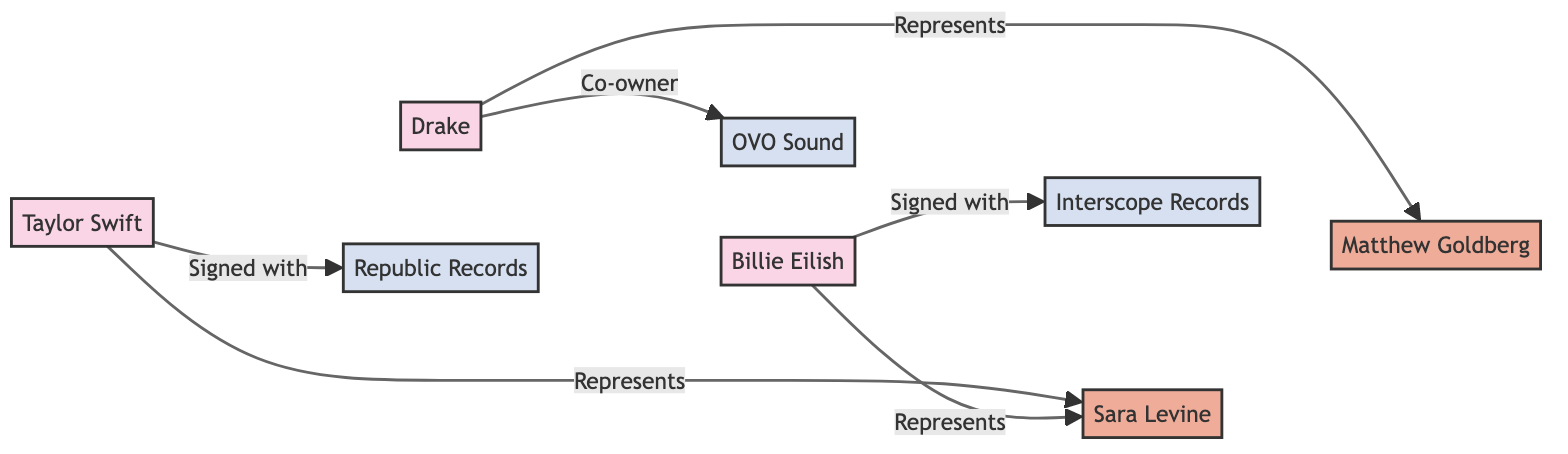What artist is represented by Sara Levine? In the diagram, Sara Levine is connected to both Taylor Swift and Billie Eilish with the label "Represents." This indicates that she represents both artists.
Answer: Taylor Swift, Billie Eilish Which record label is Drake associated with? The edge labeled "Co-owner" connects Drake to OVO Sound, showing his direct association with this record label.
Answer: OVO Sound How many artists are signed with record labels? There are three edges connecting artists to record labels ("Signed with" labels). Taylor Swift is signed with Republic Records, and Billie Eilish is signed with Interscope Records. Therefore, 2 artists are signed.
Answer: 2 Who is the lawyer representing Billie Eilish? The diagram indicates that Billie Eilish is connected to Sara Levine with the label "Represents." Hence, Sara Levine is her lawyer.
Answer: Sara Levine Which artist has a direct connection with Republic Records? The diagram shows an edge labeled "Signed with" from Taylor Swift to Republic Records, indicating that she has a direct connection with this label.
Answer: Taylor Swift What is the total number of nodes in this diagram? By counting all unique entities represented in the diagram, there are 7 nodes: 3 artists, 2 lawyers, and 3 record labels. Therefore, the total is 7.
Answer: 7 How many edges indicate 'Represents' relationships? The diagram contains 3 edges labeled "Represents," one for Taylor Swift to Sara Levine, one for Billie Eilish to Sara Levine, and one for Drake to Matthew Goldberg.
Answer: 3 Which lawyer represents both Taylor Swift and Billie Eilish? The edge labeled "Represents" connects both Taylor Swift and Billie Eilish to Sara Levine, indicating she represents both artists.
Answer: Sara Levine Which record label is associated with the most artists? According to the connections, OVO Sound is associated with Drake as a co-owner, while Republic Records has Taylor Swift signed to it, and Interscope Records has Billie Eilish signed. Thus, OVO Sound is associated with one artist only.
Answer: 1 